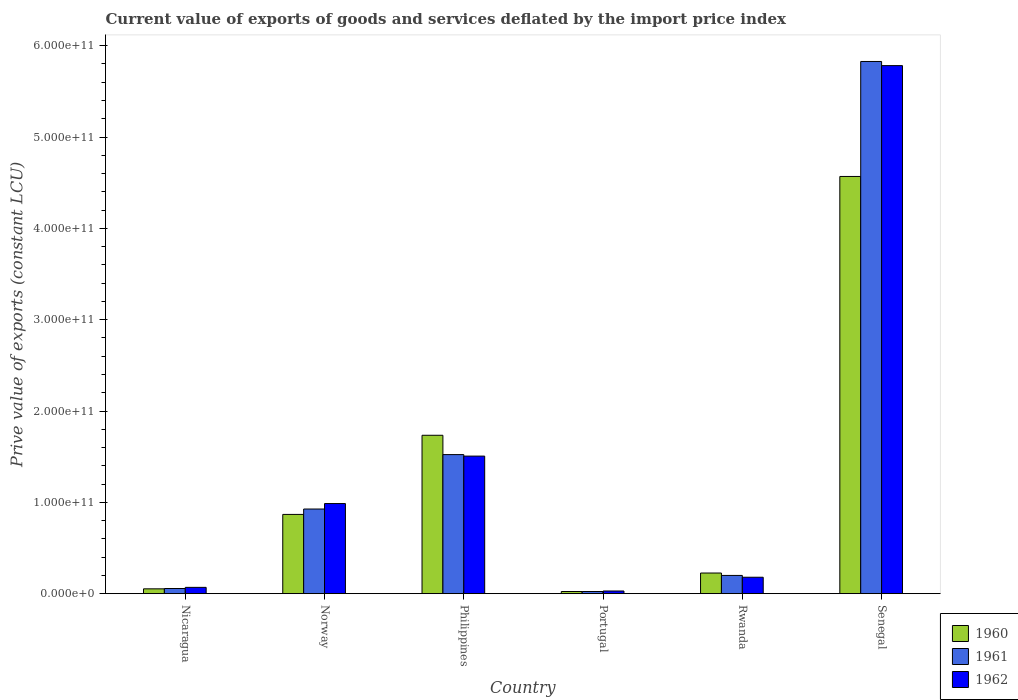How many different coloured bars are there?
Provide a succinct answer. 3. How many groups of bars are there?
Keep it short and to the point. 6. Are the number of bars on each tick of the X-axis equal?
Your response must be concise. Yes. How many bars are there on the 5th tick from the left?
Provide a succinct answer. 3. How many bars are there on the 2nd tick from the right?
Provide a succinct answer. 3. In how many cases, is the number of bars for a given country not equal to the number of legend labels?
Provide a succinct answer. 0. What is the prive value of exports in 1961 in Nicaragua?
Your response must be concise. 5.65e+09. Across all countries, what is the maximum prive value of exports in 1961?
Your response must be concise. 5.83e+11. Across all countries, what is the minimum prive value of exports in 1962?
Your answer should be very brief. 2.91e+09. In which country was the prive value of exports in 1960 maximum?
Your response must be concise. Senegal. What is the total prive value of exports in 1960 in the graph?
Give a very brief answer. 7.47e+11. What is the difference between the prive value of exports in 1960 in Philippines and that in Rwanda?
Your response must be concise. 1.51e+11. What is the difference between the prive value of exports in 1962 in Portugal and the prive value of exports in 1960 in Philippines?
Provide a succinct answer. -1.71e+11. What is the average prive value of exports in 1961 per country?
Provide a short and direct response. 1.43e+11. What is the difference between the prive value of exports of/in 1960 and prive value of exports of/in 1961 in Philippines?
Keep it short and to the point. 2.12e+1. What is the ratio of the prive value of exports in 1962 in Norway to that in Senegal?
Provide a succinct answer. 0.17. Is the prive value of exports in 1961 in Norway less than that in Rwanda?
Keep it short and to the point. No. Is the difference between the prive value of exports in 1960 in Portugal and Rwanda greater than the difference between the prive value of exports in 1961 in Portugal and Rwanda?
Give a very brief answer. No. What is the difference between the highest and the second highest prive value of exports in 1961?
Provide a short and direct response. 5.96e+1. What is the difference between the highest and the lowest prive value of exports in 1961?
Your answer should be very brief. 5.80e+11. In how many countries, is the prive value of exports in 1962 greater than the average prive value of exports in 1962 taken over all countries?
Your answer should be very brief. 2. What does the 2nd bar from the left in Rwanda represents?
Make the answer very short. 1961. Is it the case that in every country, the sum of the prive value of exports in 1960 and prive value of exports in 1961 is greater than the prive value of exports in 1962?
Provide a short and direct response. Yes. Are all the bars in the graph horizontal?
Provide a succinct answer. No. What is the difference between two consecutive major ticks on the Y-axis?
Offer a very short reply. 1.00e+11. Where does the legend appear in the graph?
Your response must be concise. Bottom right. How many legend labels are there?
Offer a terse response. 3. What is the title of the graph?
Keep it short and to the point. Current value of exports of goods and services deflated by the import price index. What is the label or title of the Y-axis?
Keep it short and to the point. Prive value of exports (constant LCU). What is the Prive value of exports (constant LCU) in 1960 in Nicaragua?
Offer a terse response. 5.28e+09. What is the Prive value of exports (constant LCU) of 1961 in Nicaragua?
Make the answer very short. 5.65e+09. What is the Prive value of exports (constant LCU) of 1962 in Nicaragua?
Provide a succinct answer. 6.89e+09. What is the Prive value of exports (constant LCU) in 1960 in Norway?
Keep it short and to the point. 8.68e+1. What is the Prive value of exports (constant LCU) in 1961 in Norway?
Your response must be concise. 9.27e+1. What is the Prive value of exports (constant LCU) of 1962 in Norway?
Your answer should be very brief. 9.87e+1. What is the Prive value of exports (constant LCU) of 1960 in Philippines?
Your response must be concise. 1.73e+11. What is the Prive value of exports (constant LCU) in 1961 in Philippines?
Give a very brief answer. 1.52e+11. What is the Prive value of exports (constant LCU) in 1962 in Philippines?
Make the answer very short. 1.51e+11. What is the Prive value of exports (constant LCU) of 1960 in Portugal?
Ensure brevity in your answer.  2.36e+09. What is the Prive value of exports (constant LCU) in 1961 in Portugal?
Keep it short and to the point. 2.36e+09. What is the Prive value of exports (constant LCU) in 1962 in Portugal?
Keep it short and to the point. 2.91e+09. What is the Prive value of exports (constant LCU) of 1960 in Rwanda?
Give a very brief answer. 2.26e+1. What is the Prive value of exports (constant LCU) of 1961 in Rwanda?
Provide a succinct answer. 2.00e+1. What is the Prive value of exports (constant LCU) in 1962 in Rwanda?
Keep it short and to the point. 1.80e+1. What is the Prive value of exports (constant LCU) in 1960 in Senegal?
Ensure brevity in your answer.  4.57e+11. What is the Prive value of exports (constant LCU) in 1961 in Senegal?
Keep it short and to the point. 5.83e+11. What is the Prive value of exports (constant LCU) in 1962 in Senegal?
Your answer should be compact. 5.78e+11. Across all countries, what is the maximum Prive value of exports (constant LCU) in 1960?
Provide a short and direct response. 4.57e+11. Across all countries, what is the maximum Prive value of exports (constant LCU) of 1961?
Make the answer very short. 5.83e+11. Across all countries, what is the maximum Prive value of exports (constant LCU) in 1962?
Offer a terse response. 5.78e+11. Across all countries, what is the minimum Prive value of exports (constant LCU) in 1960?
Your answer should be very brief. 2.36e+09. Across all countries, what is the minimum Prive value of exports (constant LCU) in 1961?
Ensure brevity in your answer.  2.36e+09. Across all countries, what is the minimum Prive value of exports (constant LCU) of 1962?
Your response must be concise. 2.91e+09. What is the total Prive value of exports (constant LCU) of 1960 in the graph?
Give a very brief answer. 7.47e+11. What is the total Prive value of exports (constant LCU) in 1961 in the graph?
Make the answer very short. 8.56e+11. What is the total Prive value of exports (constant LCU) in 1962 in the graph?
Offer a terse response. 8.55e+11. What is the difference between the Prive value of exports (constant LCU) in 1960 in Nicaragua and that in Norway?
Ensure brevity in your answer.  -8.15e+1. What is the difference between the Prive value of exports (constant LCU) of 1961 in Nicaragua and that in Norway?
Make the answer very short. -8.70e+1. What is the difference between the Prive value of exports (constant LCU) in 1962 in Nicaragua and that in Norway?
Ensure brevity in your answer.  -9.18e+1. What is the difference between the Prive value of exports (constant LCU) of 1960 in Nicaragua and that in Philippines?
Ensure brevity in your answer.  -1.68e+11. What is the difference between the Prive value of exports (constant LCU) in 1961 in Nicaragua and that in Philippines?
Make the answer very short. -1.47e+11. What is the difference between the Prive value of exports (constant LCU) of 1962 in Nicaragua and that in Philippines?
Give a very brief answer. -1.44e+11. What is the difference between the Prive value of exports (constant LCU) in 1960 in Nicaragua and that in Portugal?
Your answer should be compact. 2.92e+09. What is the difference between the Prive value of exports (constant LCU) of 1961 in Nicaragua and that in Portugal?
Provide a short and direct response. 3.29e+09. What is the difference between the Prive value of exports (constant LCU) of 1962 in Nicaragua and that in Portugal?
Provide a succinct answer. 3.98e+09. What is the difference between the Prive value of exports (constant LCU) of 1960 in Nicaragua and that in Rwanda?
Give a very brief answer. -1.73e+1. What is the difference between the Prive value of exports (constant LCU) in 1961 in Nicaragua and that in Rwanda?
Provide a succinct answer. -1.43e+1. What is the difference between the Prive value of exports (constant LCU) of 1962 in Nicaragua and that in Rwanda?
Keep it short and to the point. -1.11e+1. What is the difference between the Prive value of exports (constant LCU) of 1960 in Nicaragua and that in Senegal?
Your answer should be very brief. -4.52e+11. What is the difference between the Prive value of exports (constant LCU) in 1961 in Nicaragua and that in Senegal?
Keep it short and to the point. -5.77e+11. What is the difference between the Prive value of exports (constant LCU) of 1962 in Nicaragua and that in Senegal?
Provide a succinct answer. -5.71e+11. What is the difference between the Prive value of exports (constant LCU) in 1960 in Norway and that in Philippines?
Ensure brevity in your answer.  -8.67e+1. What is the difference between the Prive value of exports (constant LCU) of 1961 in Norway and that in Philippines?
Your answer should be very brief. -5.96e+1. What is the difference between the Prive value of exports (constant LCU) in 1962 in Norway and that in Philippines?
Offer a very short reply. -5.20e+1. What is the difference between the Prive value of exports (constant LCU) in 1960 in Norway and that in Portugal?
Make the answer very short. 8.44e+1. What is the difference between the Prive value of exports (constant LCU) of 1961 in Norway and that in Portugal?
Offer a very short reply. 9.03e+1. What is the difference between the Prive value of exports (constant LCU) in 1962 in Norway and that in Portugal?
Your response must be concise. 9.57e+1. What is the difference between the Prive value of exports (constant LCU) in 1960 in Norway and that in Rwanda?
Provide a short and direct response. 6.42e+1. What is the difference between the Prive value of exports (constant LCU) in 1961 in Norway and that in Rwanda?
Provide a succinct answer. 7.27e+1. What is the difference between the Prive value of exports (constant LCU) in 1962 in Norway and that in Rwanda?
Your response must be concise. 8.07e+1. What is the difference between the Prive value of exports (constant LCU) of 1960 in Norway and that in Senegal?
Offer a terse response. -3.70e+11. What is the difference between the Prive value of exports (constant LCU) of 1961 in Norway and that in Senegal?
Provide a short and direct response. -4.90e+11. What is the difference between the Prive value of exports (constant LCU) of 1962 in Norway and that in Senegal?
Ensure brevity in your answer.  -4.80e+11. What is the difference between the Prive value of exports (constant LCU) of 1960 in Philippines and that in Portugal?
Your answer should be compact. 1.71e+11. What is the difference between the Prive value of exports (constant LCU) of 1961 in Philippines and that in Portugal?
Your answer should be compact. 1.50e+11. What is the difference between the Prive value of exports (constant LCU) in 1962 in Philippines and that in Portugal?
Give a very brief answer. 1.48e+11. What is the difference between the Prive value of exports (constant LCU) of 1960 in Philippines and that in Rwanda?
Give a very brief answer. 1.51e+11. What is the difference between the Prive value of exports (constant LCU) of 1961 in Philippines and that in Rwanda?
Your answer should be very brief. 1.32e+11. What is the difference between the Prive value of exports (constant LCU) in 1962 in Philippines and that in Rwanda?
Make the answer very short. 1.33e+11. What is the difference between the Prive value of exports (constant LCU) in 1960 in Philippines and that in Senegal?
Provide a short and direct response. -2.83e+11. What is the difference between the Prive value of exports (constant LCU) of 1961 in Philippines and that in Senegal?
Ensure brevity in your answer.  -4.30e+11. What is the difference between the Prive value of exports (constant LCU) in 1962 in Philippines and that in Senegal?
Your response must be concise. -4.28e+11. What is the difference between the Prive value of exports (constant LCU) of 1960 in Portugal and that in Rwanda?
Make the answer very short. -2.02e+1. What is the difference between the Prive value of exports (constant LCU) of 1961 in Portugal and that in Rwanda?
Make the answer very short. -1.76e+1. What is the difference between the Prive value of exports (constant LCU) of 1962 in Portugal and that in Rwanda?
Offer a terse response. -1.51e+1. What is the difference between the Prive value of exports (constant LCU) in 1960 in Portugal and that in Senegal?
Ensure brevity in your answer.  -4.54e+11. What is the difference between the Prive value of exports (constant LCU) in 1961 in Portugal and that in Senegal?
Your answer should be compact. -5.80e+11. What is the difference between the Prive value of exports (constant LCU) in 1962 in Portugal and that in Senegal?
Your response must be concise. -5.75e+11. What is the difference between the Prive value of exports (constant LCU) of 1960 in Rwanda and that in Senegal?
Your response must be concise. -4.34e+11. What is the difference between the Prive value of exports (constant LCU) of 1961 in Rwanda and that in Senegal?
Offer a terse response. -5.63e+11. What is the difference between the Prive value of exports (constant LCU) of 1962 in Rwanda and that in Senegal?
Give a very brief answer. -5.60e+11. What is the difference between the Prive value of exports (constant LCU) of 1960 in Nicaragua and the Prive value of exports (constant LCU) of 1961 in Norway?
Provide a short and direct response. -8.74e+1. What is the difference between the Prive value of exports (constant LCU) of 1960 in Nicaragua and the Prive value of exports (constant LCU) of 1962 in Norway?
Offer a terse response. -9.34e+1. What is the difference between the Prive value of exports (constant LCU) in 1961 in Nicaragua and the Prive value of exports (constant LCU) in 1962 in Norway?
Keep it short and to the point. -9.30e+1. What is the difference between the Prive value of exports (constant LCU) in 1960 in Nicaragua and the Prive value of exports (constant LCU) in 1961 in Philippines?
Give a very brief answer. -1.47e+11. What is the difference between the Prive value of exports (constant LCU) of 1960 in Nicaragua and the Prive value of exports (constant LCU) of 1962 in Philippines?
Your response must be concise. -1.45e+11. What is the difference between the Prive value of exports (constant LCU) of 1961 in Nicaragua and the Prive value of exports (constant LCU) of 1962 in Philippines?
Keep it short and to the point. -1.45e+11. What is the difference between the Prive value of exports (constant LCU) of 1960 in Nicaragua and the Prive value of exports (constant LCU) of 1961 in Portugal?
Provide a short and direct response. 2.92e+09. What is the difference between the Prive value of exports (constant LCU) of 1960 in Nicaragua and the Prive value of exports (constant LCU) of 1962 in Portugal?
Your response must be concise. 2.37e+09. What is the difference between the Prive value of exports (constant LCU) of 1961 in Nicaragua and the Prive value of exports (constant LCU) of 1962 in Portugal?
Your answer should be very brief. 2.73e+09. What is the difference between the Prive value of exports (constant LCU) of 1960 in Nicaragua and the Prive value of exports (constant LCU) of 1961 in Rwanda?
Give a very brief answer. -1.47e+1. What is the difference between the Prive value of exports (constant LCU) of 1960 in Nicaragua and the Prive value of exports (constant LCU) of 1962 in Rwanda?
Offer a very short reply. -1.27e+1. What is the difference between the Prive value of exports (constant LCU) of 1961 in Nicaragua and the Prive value of exports (constant LCU) of 1962 in Rwanda?
Offer a terse response. -1.23e+1. What is the difference between the Prive value of exports (constant LCU) in 1960 in Nicaragua and the Prive value of exports (constant LCU) in 1961 in Senegal?
Provide a short and direct response. -5.77e+11. What is the difference between the Prive value of exports (constant LCU) of 1960 in Nicaragua and the Prive value of exports (constant LCU) of 1962 in Senegal?
Offer a very short reply. -5.73e+11. What is the difference between the Prive value of exports (constant LCU) in 1961 in Nicaragua and the Prive value of exports (constant LCU) in 1962 in Senegal?
Offer a terse response. -5.73e+11. What is the difference between the Prive value of exports (constant LCU) in 1960 in Norway and the Prive value of exports (constant LCU) in 1961 in Philippines?
Offer a terse response. -6.55e+1. What is the difference between the Prive value of exports (constant LCU) of 1960 in Norway and the Prive value of exports (constant LCU) of 1962 in Philippines?
Ensure brevity in your answer.  -6.39e+1. What is the difference between the Prive value of exports (constant LCU) of 1961 in Norway and the Prive value of exports (constant LCU) of 1962 in Philippines?
Offer a terse response. -5.79e+1. What is the difference between the Prive value of exports (constant LCU) of 1960 in Norway and the Prive value of exports (constant LCU) of 1961 in Portugal?
Keep it short and to the point. 8.44e+1. What is the difference between the Prive value of exports (constant LCU) of 1960 in Norway and the Prive value of exports (constant LCU) of 1962 in Portugal?
Your response must be concise. 8.39e+1. What is the difference between the Prive value of exports (constant LCU) in 1961 in Norway and the Prive value of exports (constant LCU) in 1962 in Portugal?
Your answer should be very brief. 8.98e+1. What is the difference between the Prive value of exports (constant LCU) in 1960 in Norway and the Prive value of exports (constant LCU) in 1961 in Rwanda?
Give a very brief answer. 6.68e+1. What is the difference between the Prive value of exports (constant LCU) in 1960 in Norway and the Prive value of exports (constant LCU) in 1962 in Rwanda?
Keep it short and to the point. 6.88e+1. What is the difference between the Prive value of exports (constant LCU) of 1961 in Norway and the Prive value of exports (constant LCU) of 1962 in Rwanda?
Provide a succinct answer. 7.47e+1. What is the difference between the Prive value of exports (constant LCU) in 1960 in Norway and the Prive value of exports (constant LCU) in 1961 in Senegal?
Your answer should be compact. -4.96e+11. What is the difference between the Prive value of exports (constant LCU) of 1960 in Norway and the Prive value of exports (constant LCU) of 1962 in Senegal?
Keep it short and to the point. -4.91e+11. What is the difference between the Prive value of exports (constant LCU) in 1961 in Norway and the Prive value of exports (constant LCU) in 1962 in Senegal?
Offer a very short reply. -4.86e+11. What is the difference between the Prive value of exports (constant LCU) in 1960 in Philippines and the Prive value of exports (constant LCU) in 1961 in Portugal?
Offer a very short reply. 1.71e+11. What is the difference between the Prive value of exports (constant LCU) of 1960 in Philippines and the Prive value of exports (constant LCU) of 1962 in Portugal?
Your response must be concise. 1.71e+11. What is the difference between the Prive value of exports (constant LCU) of 1961 in Philippines and the Prive value of exports (constant LCU) of 1962 in Portugal?
Provide a short and direct response. 1.49e+11. What is the difference between the Prive value of exports (constant LCU) of 1960 in Philippines and the Prive value of exports (constant LCU) of 1961 in Rwanda?
Provide a short and direct response. 1.53e+11. What is the difference between the Prive value of exports (constant LCU) of 1960 in Philippines and the Prive value of exports (constant LCU) of 1962 in Rwanda?
Your answer should be compact. 1.55e+11. What is the difference between the Prive value of exports (constant LCU) of 1961 in Philippines and the Prive value of exports (constant LCU) of 1962 in Rwanda?
Give a very brief answer. 1.34e+11. What is the difference between the Prive value of exports (constant LCU) of 1960 in Philippines and the Prive value of exports (constant LCU) of 1961 in Senegal?
Your answer should be compact. -4.09e+11. What is the difference between the Prive value of exports (constant LCU) of 1960 in Philippines and the Prive value of exports (constant LCU) of 1962 in Senegal?
Your response must be concise. -4.05e+11. What is the difference between the Prive value of exports (constant LCU) in 1961 in Philippines and the Prive value of exports (constant LCU) in 1962 in Senegal?
Offer a very short reply. -4.26e+11. What is the difference between the Prive value of exports (constant LCU) of 1960 in Portugal and the Prive value of exports (constant LCU) of 1961 in Rwanda?
Provide a short and direct response. -1.76e+1. What is the difference between the Prive value of exports (constant LCU) in 1960 in Portugal and the Prive value of exports (constant LCU) in 1962 in Rwanda?
Make the answer very short. -1.56e+1. What is the difference between the Prive value of exports (constant LCU) of 1961 in Portugal and the Prive value of exports (constant LCU) of 1962 in Rwanda?
Give a very brief answer. -1.56e+1. What is the difference between the Prive value of exports (constant LCU) in 1960 in Portugal and the Prive value of exports (constant LCU) in 1961 in Senegal?
Provide a succinct answer. -5.80e+11. What is the difference between the Prive value of exports (constant LCU) of 1960 in Portugal and the Prive value of exports (constant LCU) of 1962 in Senegal?
Offer a terse response. -5.76e+11. What is the difference between the Prive value of exports (constant LCU) of 1961 in Portugal and the Prive value of exports (constant LCU) of 1962 in Senegal?
Your answer should be very brief. -5.76e+11. What is the difference between the Prive value of exports (constant LCU) of 1960 in Rwanda and the Prive value of exports (constant LCU) of 1961 in Senegal?
Provide a succinct answer. -5.60e+11. What is the difference between the Prive value of exports (constant LCU) in 1960 in Rwanda and the Prive value of exports (constant LCU) in 1962 in Senegal?
Provide a short and direct response. -5.56e+11. What is the difference between the Prive value of exports (constant LCU) of 1961 in Rwanda and the Prive value of exports (constant LCU) of 1962 in Senegal?
Offer a terse response. -5.58e+11. What is the average Prive value of exports (constant LCU) in 1960 per country?
Your answer should be very brief. 1.25e+11. What is the average Prive value of exports (constant LCU) in 1961 per country?
Offer a terse response. 1.43e+11. What is the average Prive value of exports (constant LCU) of 1962 per country?
Offer a very short reply. 1.43e+11. What is the difference between the Prive value of exports (constant LCU) in 1960 and Prive value of exports (constant LCU) in 1961 in Nicaragua?
Offer a very short reply. -3.67e+08. What is the difference between the Prive value of exports (constant LCU) in 1960 and Prive value of exports (constant LCU) in 1962 in Nicaragua?
Your response must be concise. -1.61e+09. What is the difference between the Prive value of exports (constant LCU) of 1961 and Prive value of exports (constant LCU) of 1962 in Nicaragua?
Provide a short and direct response. -1.25e+09. What is the difference between the Prive value of exports (constant LCU) of 1960 and Prive value of exports (constant LCU) of 1961 in Norway?
Offer a terse response. -5.90e+09. What is the difference between the Prive value of exports (constant LCU) of 1960 and Prive value of exports (constant LCU) of 1962 in Norway?
Offer a terse response. -1.19e+1. What is the difference between the Prive value of exports (constant LCU) of 1961 and Prive value of exports (constant LCU) of 1962 in Norway?
Your answer should be very brief. -5.98e+09. What is the difference between the Prive value of exports (constant LCU) of 1960 and Prive value of exports (constant LCU) of 1961 in Philippines?
Ensure brevity in your answer.  2.12e+1. What is the difference between the Prive value of exports (constant LCU) of 1960 and Prive value of exports (constant LCU) of 1962 in Philippines?
Offer a terse response. 2.28e+1. What is the difference between the Prive value of exports (constant LCU) in 1961 and Prive value of exports (constant LCU) in 1962 in Philippines?
Make the answer very short. 1.65e+09. What is the difference between the Prive value of exports (constant LCU) in 1960 and Prive value of exports (constant LCU) in 1961 in Portugal?
Provide a succinct answer. 2.01e+06. What is the difference between the Prive value of exports (constant LCU) in 1960 and Prive value of exports (constant LCU) in 1962 in Portugal?
Your answer should be very brief. -5.51e+08. What is the difference between the Prive value of exports (constant LCU) in 1961 and Prive value of exports (constant LCU) in 1962 in Portugal?
Ensure brevity in your answer.  -5.53e+08. What is the difference between the Prive value of exports (constant LCU) of 1960 and Prive value of exports (constant LCU) of 1961 in Rwanda?
Your response must be concise. 2.64e+09. What is the difference between the Prive value of exports (constant LCU) of 1960 and Prive value of exports (constant LCU) of 1962 in Rwanda?
Make the answer very short. 4.63e+09. What is the difference between the Prive value of exports (constant LCU) in 1961 and Prive value of exports (constant LCU) in 1962 in Rwanda?
Give a very brief answer. 1.99e+09. What is the difference between the Prive value of exports (constant LCU) in 1960 and Prive value of exports (constant LCU) in 1961 in Senegal?
Offer a very short reply. -1.26e+11. What is the difference between the Prive value of exports (constant LCU) in 1960 and Prive value of exports (constant LCU) in 1962 in Senegal?
Your response must be concise. -1.21e+11. What is the difference between the Prive value of exports (constant LCU) in 1961 and Prive value of exports (constant LCU) in 1962 in Senegal?
Make the answer very short. 4.52e+09. What is the ratio of the Prive value of exports (constant LCU) in 1960 in Nicaragua to that in Norway?
Keep it short and to the point. 0.06. What is the ratio of the Prive value of exports (constant LCU) of 1961 in Nicaragua to that in Norway?
Make the answer very short. 0.06. What is the ratio of the Prive value of exports (constant LCU) of 1962 in Nicaragua to that in Norway?
Give a very brief answer. 0.07. What is the ratio of the Prive value of exports (constant LCU) in 1960 in Nicaragua to that in Philippines?
Provide a short and direct response. 0.03. What is the ratio of the Prive value of exports (constant LCU) in 1961 in Nicaragua to that in Philippines?
Your answer should be very brief. 0.04. What is the ratio of the Prive value of exports (constant LCU) in 1962 in Nicaragua to that in Philippines?
Give a very brief answer. 0.05. What is the ratio of the Prive value of exports (constant LCU) in 1960 in Nicaragua to that in Portugal?
Offer a very short reply. 2.23. What is the ratio of the Prive value of exports (constant LCU) in 1961 in Nicaragua to that in Portugal?
Offer a very short reply. 2.39. What is the ratio of the Prive value of exports (constant LCU) of 1962 in Nicaragua to that in Portugal?
Your response must be concise. 2.37. What is the ratio of the Prive value of exports (constant LCU) of 1960 in Nicaragua to that in Rwanda?
Offer a very short reply. 0.23. What is the ratio of the Prive value of exports (constant LCU) in 1961 in Nicaragua to that in Rwanda?
Your response must be concise. 0.28. What is the ratio of the Prive value of exports (constant LCU) of 1962 in Nicaragua to that in Rwanda?
Offer a very short reply. 0.38. What is the ratio of the Prive value of exports (constant LCU) in 1960 in Nicaragua to that in Senegal?
Your response must be concise. 0.01. What is the ratio of the Prive value of exports (constant LCU) in 1961 in Nicaragua to that in Senegal?
Offer a terse response. 0.01. What is the ratio of the Prive value of exports (constant LCU) of 1962 in Nicaragua to that in Senegal?
Your answer should be very brief. 0.01. What is the ratio of the Prive value of exports (constant LCU) of 1960 in Norway to that in Philippines?
Give a very brief answer. 0.5. What is the ratio of the Prive value of exports (constant LCU) of 1961 in Norway to that in Philippines?
Give a very brief answer. 0.61. What is the ratio of the Prive value of exports (constant LCU) of 1962 in Norway to that in Philippines?
Ensure brevity in your answer.  0.66. What is the ratio of the Prive value of exports (constant LCU) of 1960 in Norway to that in Portugal?
Keep it short and to the point. 36.73. What is the ratio of the Prive value of exports (constant LCU) in 1961 in Norway to that in Portugal?
Make the answer very short. 39.27. What is the ratio of the Prive value of exports (constant LCU) of 1962 in Norway to that in Portugal?
Give a very brief answer. 33.87. What is the ratio of the Prive value of exports (constant LCU) in 1960 in Norway to that in Rwanda?
Ensure brevity in your answer.  3.84. What is the ratio of the Prive value of exports (constant LCU) in 1961 in Norway to that in Rwanda?
Your answer should be very brief. 4.64. What is the ratio of the Prive value of exports (constant LCU) of 1962 in Norway to that in Rwanda?
Offer a very short reply. 5.49. What is the ratio of the Prive value of exports (constant LCU) of 1960 in Norway to that in Senegal?
Provide a succinct answer. 0.19. What is the ratio of the Prive value of exports (constant LCU) in 1961 in Norway to that in Senegal?
Your answer should be very brief. 0.16. What is the ratio of the Prive value of exports (constant LCU) of 1962 in Norway to that in Senegal?
Your answer should be compact. 0.17. What is the ratio of the Prive value of exports (constant LCU) of 1960 in Philippines to that in Portugal?
Offer a terse response. 73.42. What is the ratio of the Prive value of exports (constant LCU) in 1961 in Philippines to that in Portugal?
Give a very brief answer. 64.52. What is the ratio of the Prive value of exports (constant LCU) in 1962 in Philippines to that in Portugal?
Your answer should be compact. 51.71. What is the ratio of the Prive value of exports (constant LCU) of 1960 in Philippines to that in Rwanda?
Give a very brief answer. 7.67. What is the ratio of the Prive value of exports (constant LCU) of 1961 in Philippines to that in Rwanda?
Your answer should be very brief. 7.63. What is the ratio of the Prive value of exports (constant LCU) in 1962 in Philippines to that in Rwanda?
Provide a succinct answer. 8.38. What is the ratio of the Prive value of exports (constant LCU) of 1960 in Philippines to that in Senegal?
Offer a terse response. 0.38. What is the ratio of the Prive value of exports (constant LCU) of 1961 in Philippines to that in Senegal?
Give a very brief answer. 0.26. What is the ratio of the Prive value of exports (constant LCU) in 1962 in Philippines to that in Senegal?
Your answer should be very brief. 0.26. What is the ratio of the Prive value of exports (constant LCU) of 1960 in Portugal to that in Rwanda?
Give a very brief answer. 0.1. What is the ratio of the Prive value of exports (constant LCU) in 1961 in Portugal to that in Rwanda?
Ensure brevity in your answer.  0.12. What is the ratio of the Prive value of exports (constant LCU) in 1962 in Portugal to that in Rwanda?
Your answer should be compact. 0.16. What is the ratio of the Prive value of exports (constant LCU) of 1960 in Portugal to that in Senegal?
Make the answer very short. 0.01. What is the ratio of the Prive value of exports (constant LCU) in 1961 in Portugal to that in Senegal?
Ensure brevity in your answer.  0. What is the ratio of the Prive value of exports (constant LCU) of 1962 in Portugal to that in Senegal?
Make the answer very short. 0.01. What is the ratio of the Prive value of exports (constant LCU) in 1960 in Rwanda to that in Senegal?
Keep it short and to the point. 0.05. What is the ratio of the Prive value of exports (constant LCU) in 1961 in Rwanda to that in Senegal?
Give a very brief answer. 0.03. What is the ratio of the Prive value of exports (constant LCU) in 1962 in Rwanda to that in Senegal?
Your response must be concise. 0.03. What is the difference between the highest and the second highest Prive value of exports (constant LCU) of 1960?
Provide a succinct answer. 2.83e+11. What is the difference between the highest and the second highest Prive value of exports (constant LCU) in 1961?
Keep it short and to the point. 4.30e+11. What is the difference between the highest and the second highest Prive value of exports (constant LCU) in 1962?
Your answer should be compact. 4.28e+11. What is the difference between the highest and the lowest Prive value of exports (constant LCU) of 1960?
Your response must be concise. 4.54e+11. What is the difference between the highest and the lowest Prive value of exports (constant LCU) of 1961?
Your answer should be compact. 5.80e+11. What is the difference between the highest and the lowest Prive value of exports (constant LCU) of 1962?
Give a very brief answer. 5.75e+11. 